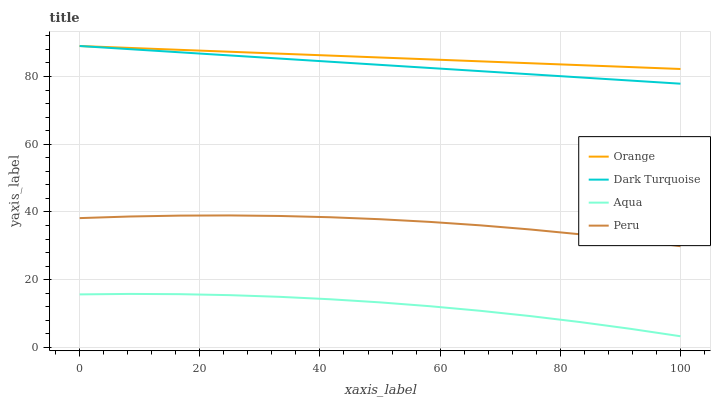Does Aqua have the minimum area under the curve?
Answer yes or no. Yes. Does Orange have the maximum area under the curve?
Answer yes or no. Yes. Does Dark Turquoise have the minimum area under the curve?
Answer yes or no. No. Does Dark Turquoise have the maximum area under the curve?
Answer yes or no. No. Is Dark Turquoise the smoothest?
Answer yes or no. Yes. Is Aqua the roughest?
Answer yes or no. Yes. Is Aqua the smoothest?
Answer yes or no. No. Is Dark Turquoise the roughest?
Answer yes or no. No. Does Dark Turquoise have the lowest value?
Answer yes or no. No. Does Dark Turquoise have the highest value?
Answer yes or no. Yes. Does Aqua have the highest value?
Answer yes or no. No. Is Aqua less than Orange?
Answer yes or no. Yes. Is Dark Turquoise greater than Peru?
Answer yes or no. Yes. Does Orange intersect Dark Turquoise?
Answer yes or no. Yes. Is Orange less than Dark Turquoise?
Answer yes or no. No. Is Orange greater than Dark Turquoise?
Answer yes or no. No. Does Aqua intersect Orange?
Answer yes or no. No. 